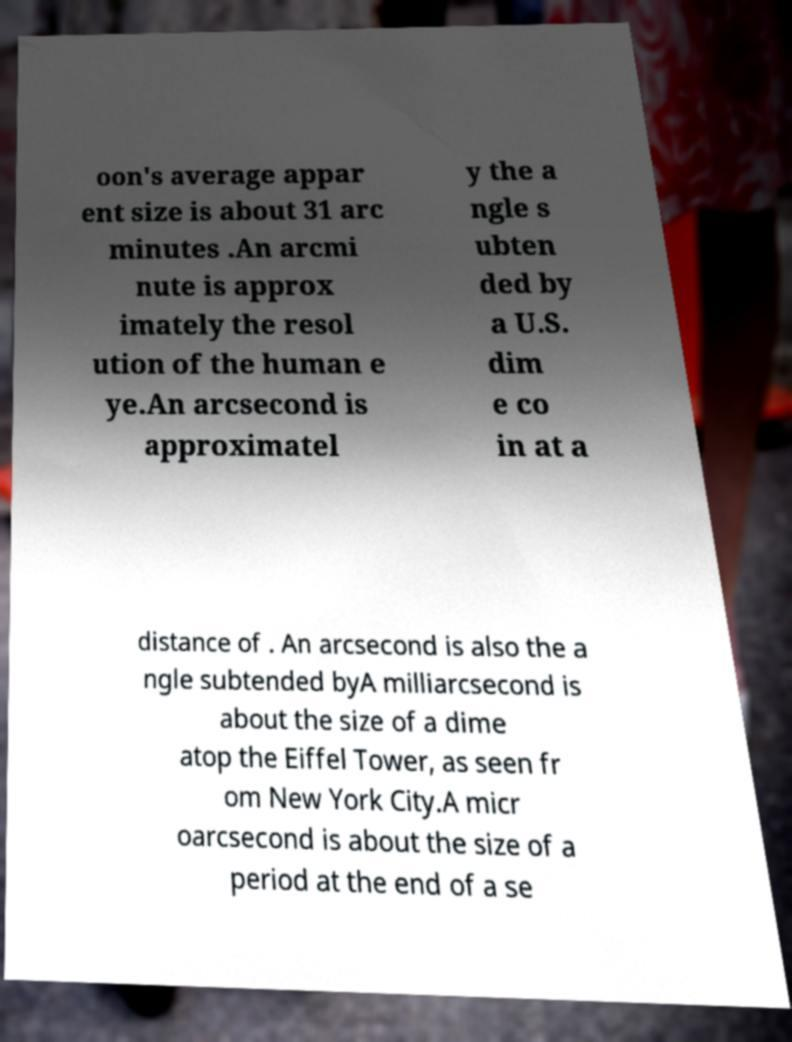Please identify and transcribe the text found in this image. oon's average appar ent size is about 31 arc minutes .An arcmi nute is approx imately the resol ution of the human e ye.An arcsecond is approximatel y the a ngle s ubten ded by a U.S. dim e co in at a distance of . An arcsecond is also the a ngle subtended byA milliarcsecond is about the size of a dime atop the Eiffel Tower, as seen fr om New York City.A micr oarcsecond is about the size of a period at the end of a se 